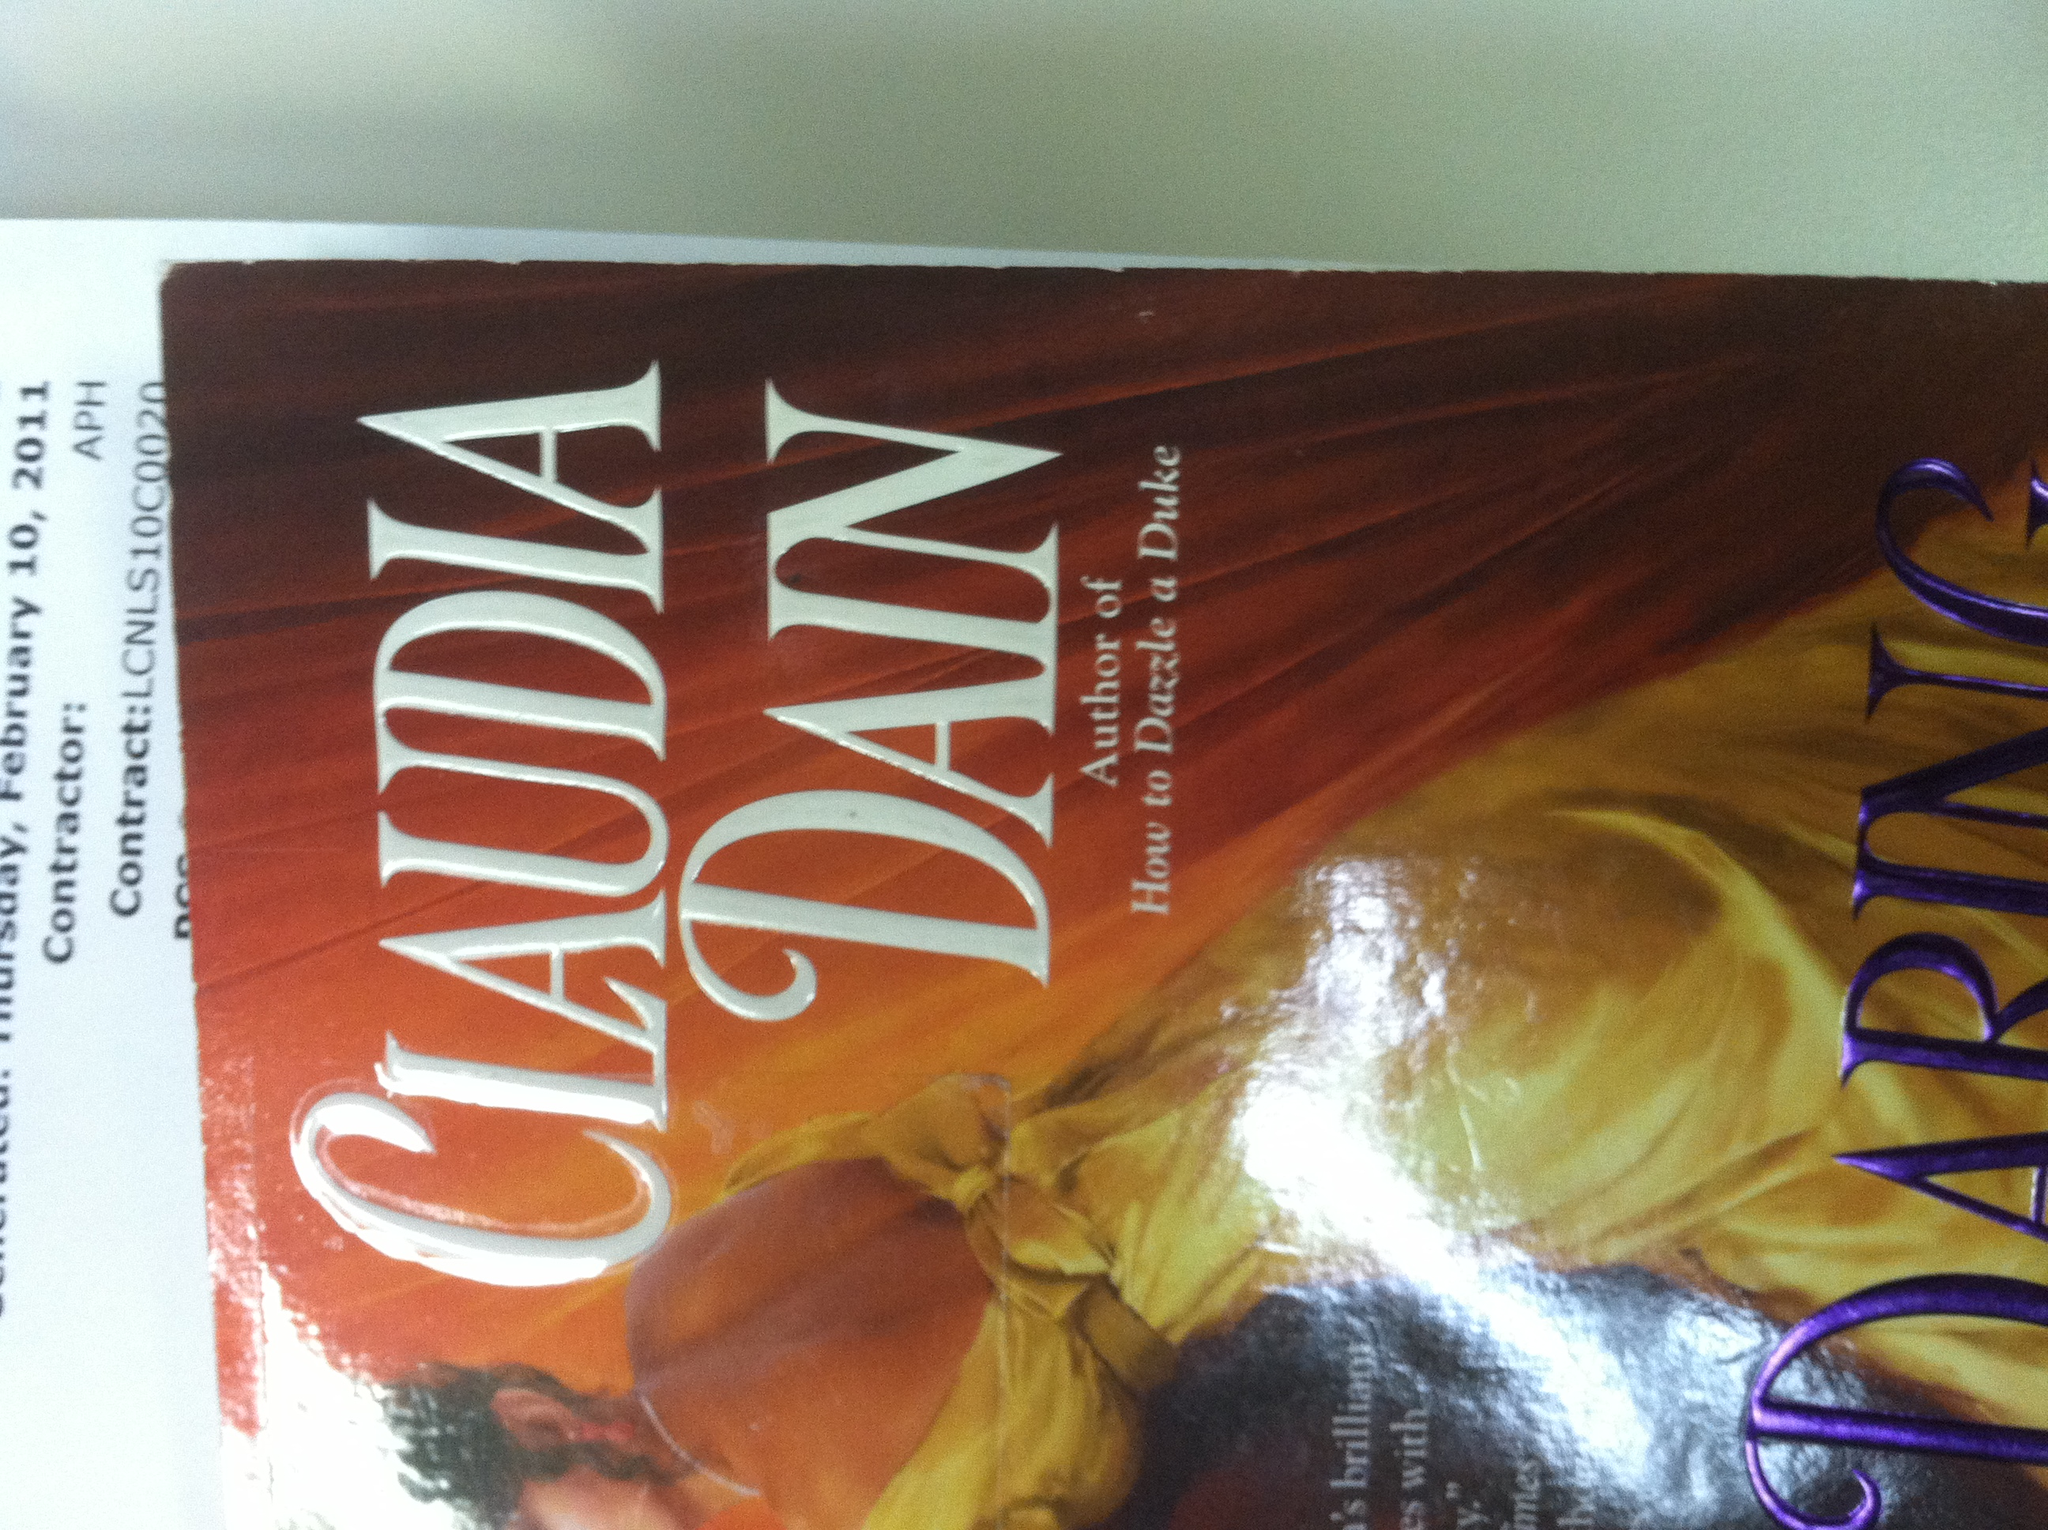What is the name or the title of this book? The title of the book shown in the image is 'Daring,' authored by Claudia Dain. 